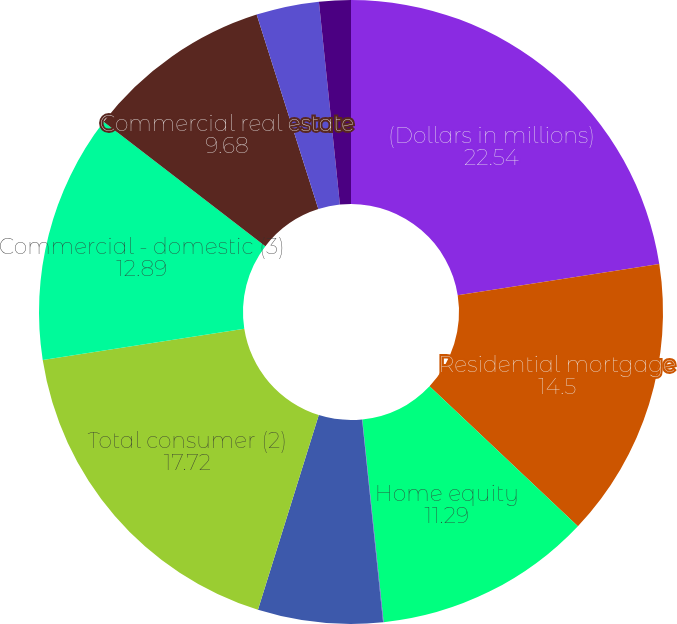Convert chart to OTSL. <chart><loc_0><loc_0><loc_500><loc_500><pie_chart><fcel>(Dollars in millions)<fcel>Residential mortgage<fcel>Home equity<fcel>Direct/Indirect consumer<fcel>Other consumer<fcel>Total consumer (2)<fcel>Commercial - domestic (3)<fcel>Commercial real estate<fcel>Commercial lease financing<fcel>Commercial - foreign<nl><fcel>22.54%<fcel>14.5%<fcel>11.29%<fcel>0.03%<fcel>6.46%<fcel>17.72%<fcel>12.89%<fcel>9.68%<fcel>3.25%<fcel>1.64%<nl></chart> 